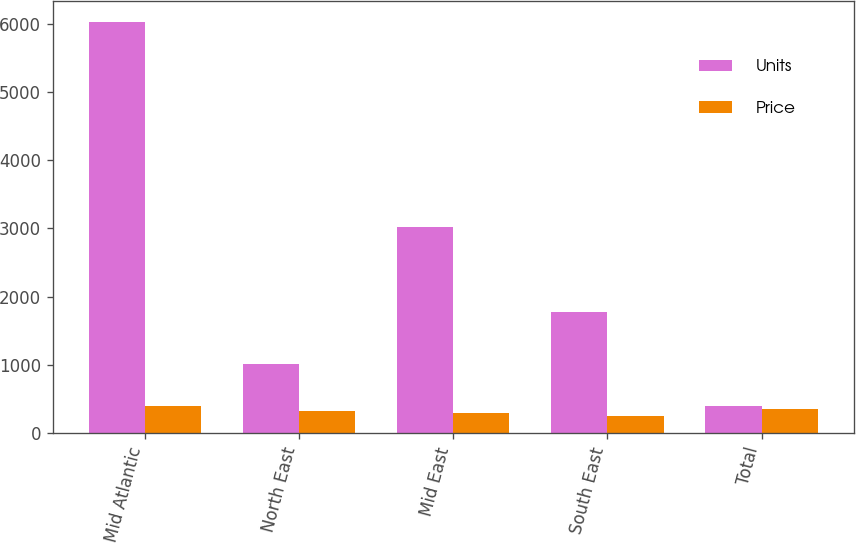Convert chart. <chart><loc_0><loc_0><loc_500><loc_500><stacked_bar_chart><ecel><fcel>Mid Atlantic<fcel>North East<fcel>Mid East<fcel>South East<fcel>Total<nl><fcel>Units<fcel>6029<fcel>1013<fcel>3023<fcel>1769<fcel>404<nl><fcel>Price<fcel>404<fcel>328.4<fcel>300.4<fcel>256.7<fcel>349.1<nl></chart> 